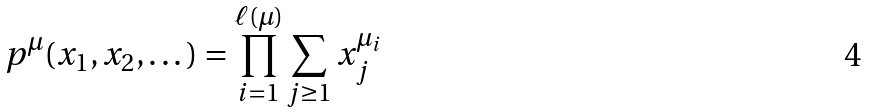Convert formula to latex. <formula><loc_0><loc_0><loc_500><loc_500>p ^ { \mu } ( x _ { 1 } , x _ { 2 } , \dots ) = \prod _ { i = 1 } ^ { \ell ( \mu ) } \sum _ { j \geq 1 } x _ { j } ^ { \mu _ { i } }</formula> 